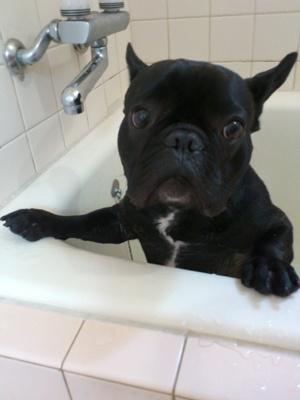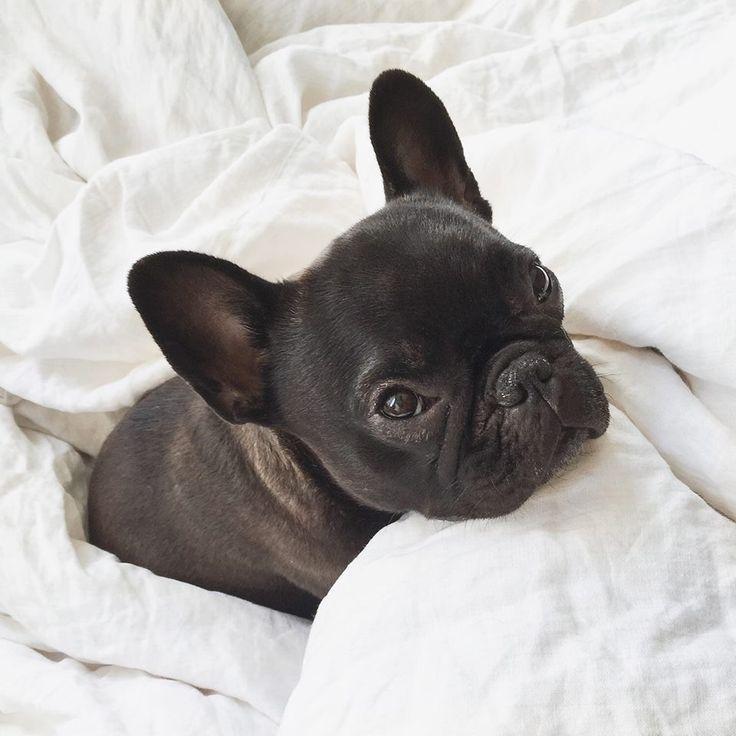The first image is the image on the left, the second image is the image on the right. Considering the images on both sides, is "The left image shows a black french bulldog pup posed with another animal figure with upright ears." valid? Answer yes or no. No. The first image is the image on the left, the second image is the image on the right. For the images shown, is this caption "One dog has something in his mouth." true? Answer yes or no. No. 